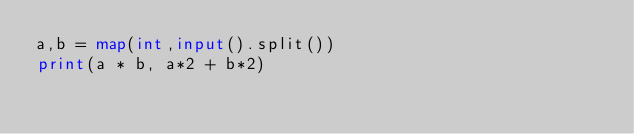<code> <loc_0><loc_0><loc_500><loc_500><_Python_>a,b = map(int,input().split())
print(a * b, a*2 + b*2)</code> 